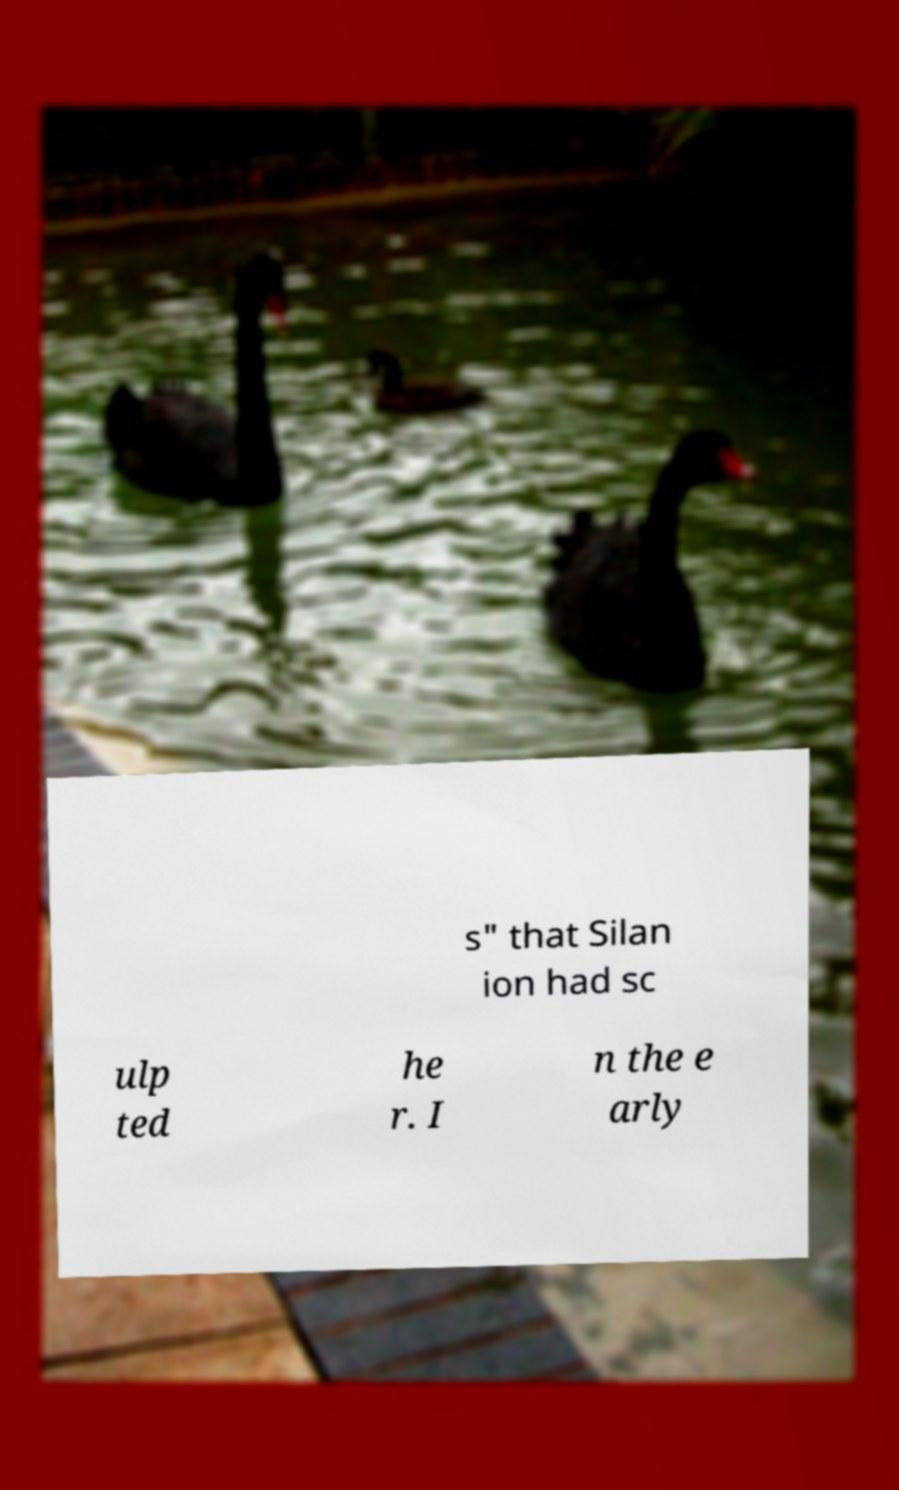Can you accurately transcribe the text from the provided image for me? s" that Silan ion had sc ulp ted he r. I n the e arly 